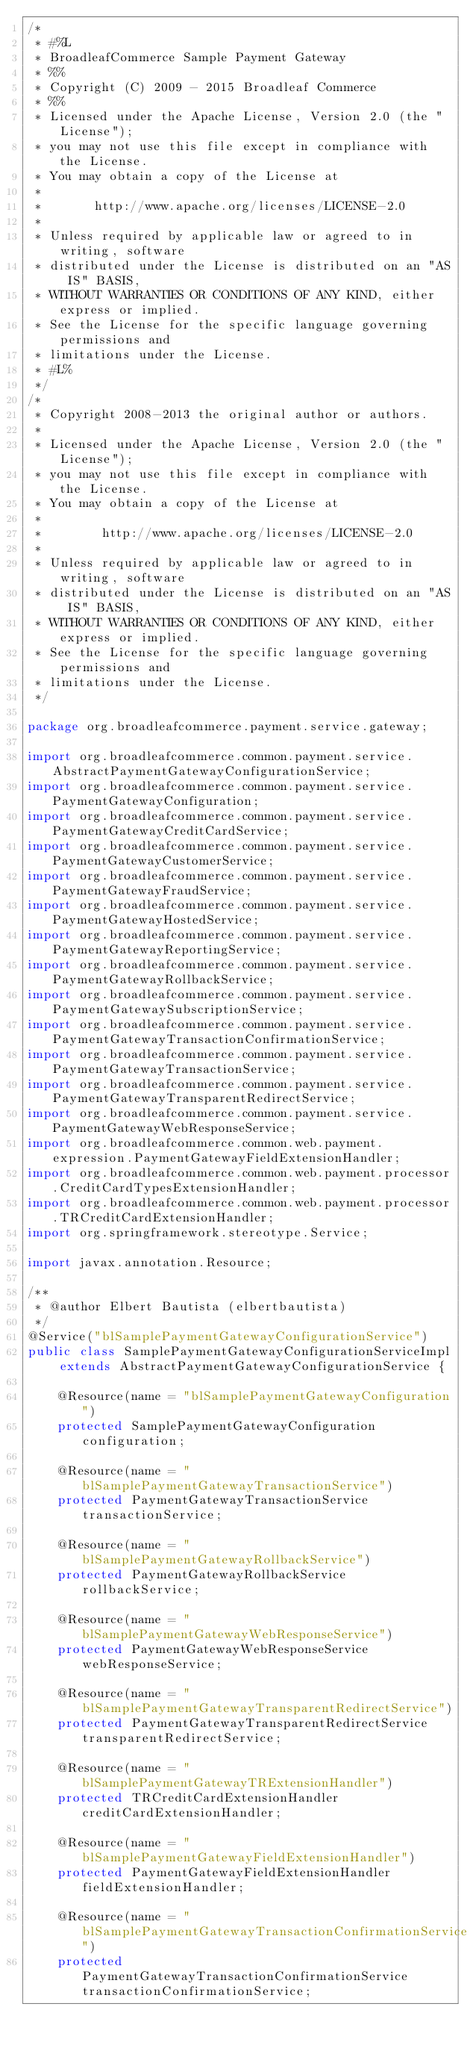<code> <loc_0><loc_0><loc_500><loc_500><_Java_>/*
 * #%L
 * BroadleafCommerce Sample Payment Gateway
 * %%
 * Copyright (C) 2009 - 2015 Broadleaf Commerce
 * %%
 * Licensed under the Apache License, Version 2.0 (the "License");
 * you may not use this file except in compliance with the License.
 * You may obtain a copy of the License at
 * 
 *       http://www.apache.org/licenses/LICENSE-2.0
 * 
 * Unless required by applicable law or agreed to in writing, software
 * distributed under the License is distributed on an "AS IS" BASIS,
 * WITHOUT WARRANTIES OR CONDITIONS OF ANY KIND, either express or implied.
 * See the License for the specific language governing permissions and
 * limitations under the License.
 * #L%
 */
/*
 * Copyright 2008-2013 the original author or authors.
 *
 * Licensed under the Apache License, Version 2.0 (the "License");
 * you may not use this file except in compliance with the License.
 * You may obtain a copy of the License at
 *
 *        http://www.apache.org/licenses/LICENSE-2.0
 *
 * Unless required by applicable law or agreed to in writing, software
 * distributed under the License is distributed on an "AS IS" BASIS,
 * WITHOUT WARRANTIES OR CONDITIONS OF ANY KIND, either express or implied.
 * See the License for the specific language governing permissions and
 * limitations under the License.
 */

package org.broadleafcommerce.payment.service.gateway;

import org.broadleafcommerce.common.payment.service.AbstractPaymentGatewayConfigurationService;
import org.broadleafcommerce.common.payment.service.PaymentGatewayConfiguration;
import org.broadleafcommerce.common.payment.service.PaymentGatewayCreditCardService;
import org.broadleafcommerce.common.payment.service.PaymentGatewayCustomerService;
import org.broadleafcommerce.common.payment.service.PaymentGatewayFraudService;
import org.broadleafcommerce.common.payment.service.PaymentGatewayHostedService;
import org.broadleafcommerce.common.payment.service.PaymentGatewayReportingService;
import org.broadleafcommerce.common.payment.service.PaymentGatewayRollbackService;
import org.broadleafcommerce.common.payment.service.PaymentGatewaySubscriptionService;
import org.broadleafcommerce.common.payment.service.PaymentGatewayTransactionConfirmationService;
import org.broadleafcommerce.common.payment.service.PaymentGatewayTransactionService;
import org.broadleafcommerce.common.payment.service.PaymentGatewayTransparentRedirectService;
import org.broadleafcommerce.common.payment.service.PaymentGatewayWebResponseService;
import org.broadleafcommerce.common.web.payment.expression.PaymentGatewayFieldExtensionHandler;
import org.broadleafcommerce.common.web.payment.processor.CreditCardTypesExtensionHandler;
import org.broadleafcommerce.common.web.payment.processor.TRCreditCardExtensionHandler;
import org.springframework.stereotype.Service;

import javax.annotation.Resource;

/**
 * @author Elbert Bautista (elbertbautista)
 */
@Service("blSamplePaymentGatewayConfigurationService")
public class SamplePaymentGatewayConfigurationServiceImpl extends AbstractPaymentGatewayConfigurationService {

    @Resource(name = "blSamplePaymentGatewayConfiguration")
    protected SamplePaymentGatewayConfiguration configuration;

    @Resource(name = "blSamplePaymentGatewayTransactionService")
    protected PaymentGatewayTransactionService transactionService;
    
    @Resource(name = "blSamplePaymentGatewayRollbackService")
    protected PaymentGatewayRollbackService rollbackService;

    @Resource(name = "blSamplePaymentGatewayWebResponseService")
    protected PaymentGatewayWebResponseService webResponseService;

    @Resource(name = "blSamplePaymentGatewayTransparentRedirectService")
    protected PaymentGatewayTransparentRedirectService transparentRedirectService;

    @Resource(name = "blSamplePaymentGatewayTRExtensionHandler")
    protected TRCreditCardExtensionHandler creditCardExtensionHandler;

    @Resource(name = "blSamplePaymentGatewayFieldExtensionHandler")
    protected PaymentGatewayFieldExtensionHandler fieldExtensionHandler;

    @Resource(name = "blSamplePaymentGatewayTransactionConfirmationService")
    protected PaymentGatewayTransactionConfirmationService transactionConfirmationService;
</code> 